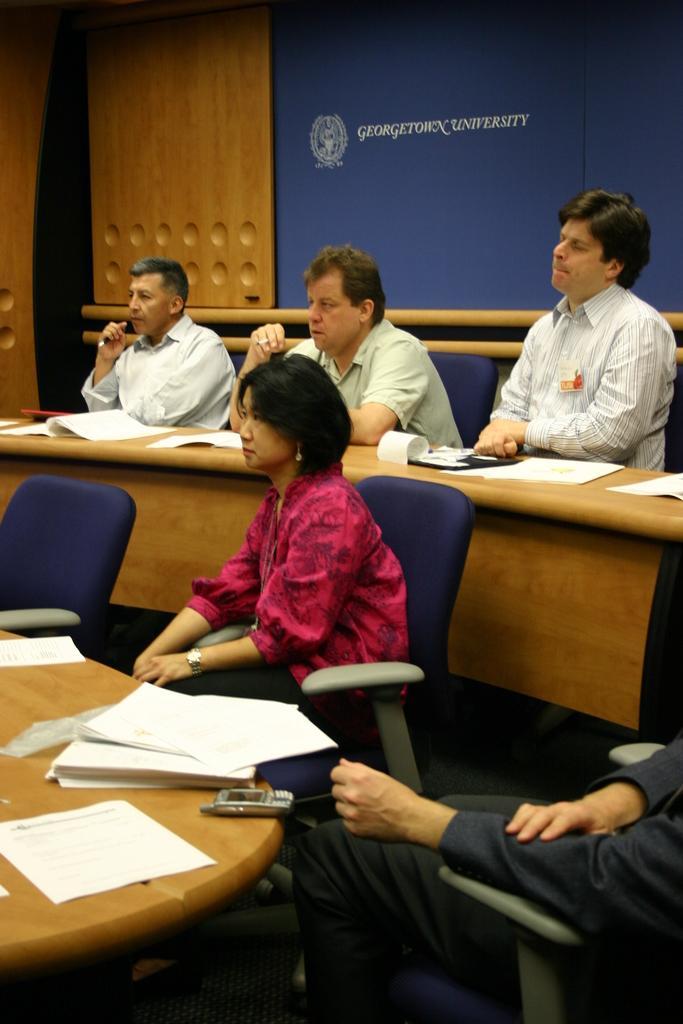How would you summarize this image in a sentence or two? In this picture I can see five persons sitting on the cars, there are papers and a mobile on the tables, and in the background there is a board. 